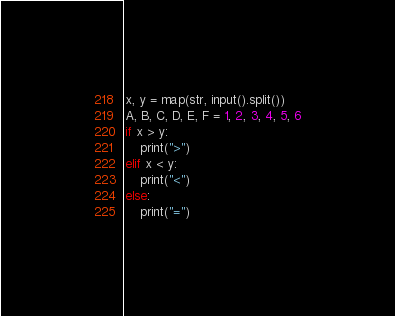Convert code to text. <code><loc_0><loc_0><loc_500><loc_500><_Python_>x, y = map(str, input().split())
A, B, C, D, E, F = 1, 2, 3, 4, 5, 6
if x > y:
	print(">")
elif x < y:
	print("<")
else:
	print("=")
</code> 